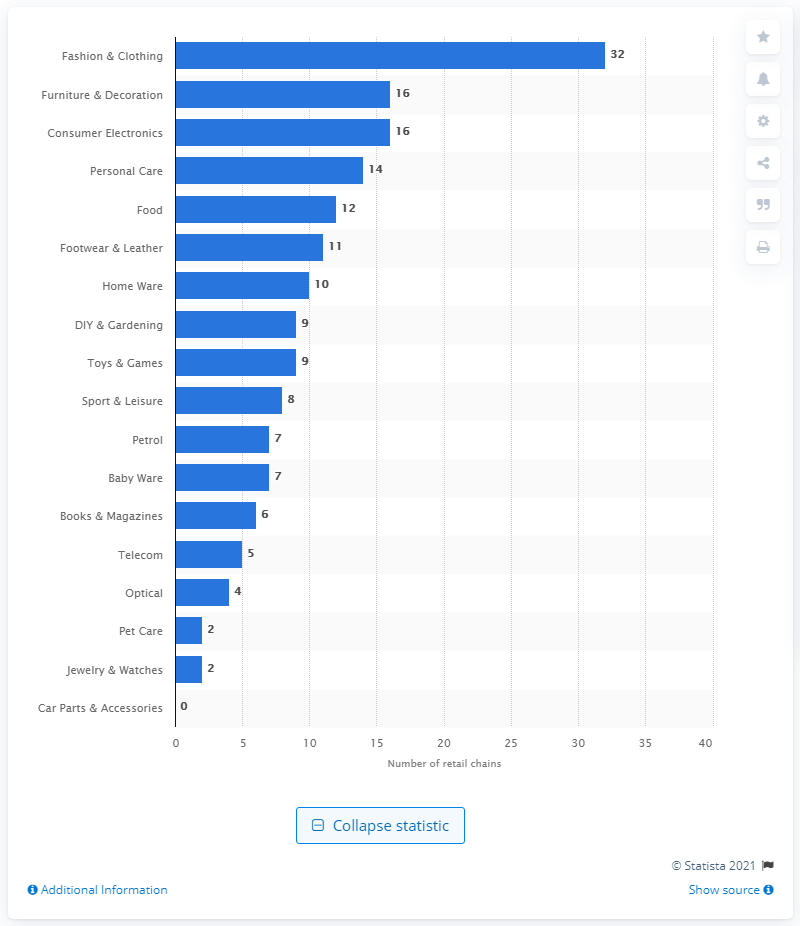List a handful of essential elements in this visual. There were 16 retail chains in the consumer electronics industry. 